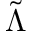<formula> <loc_0><loc_0><loc_500><loc_500>\tilde { \Lambda }</formula> 